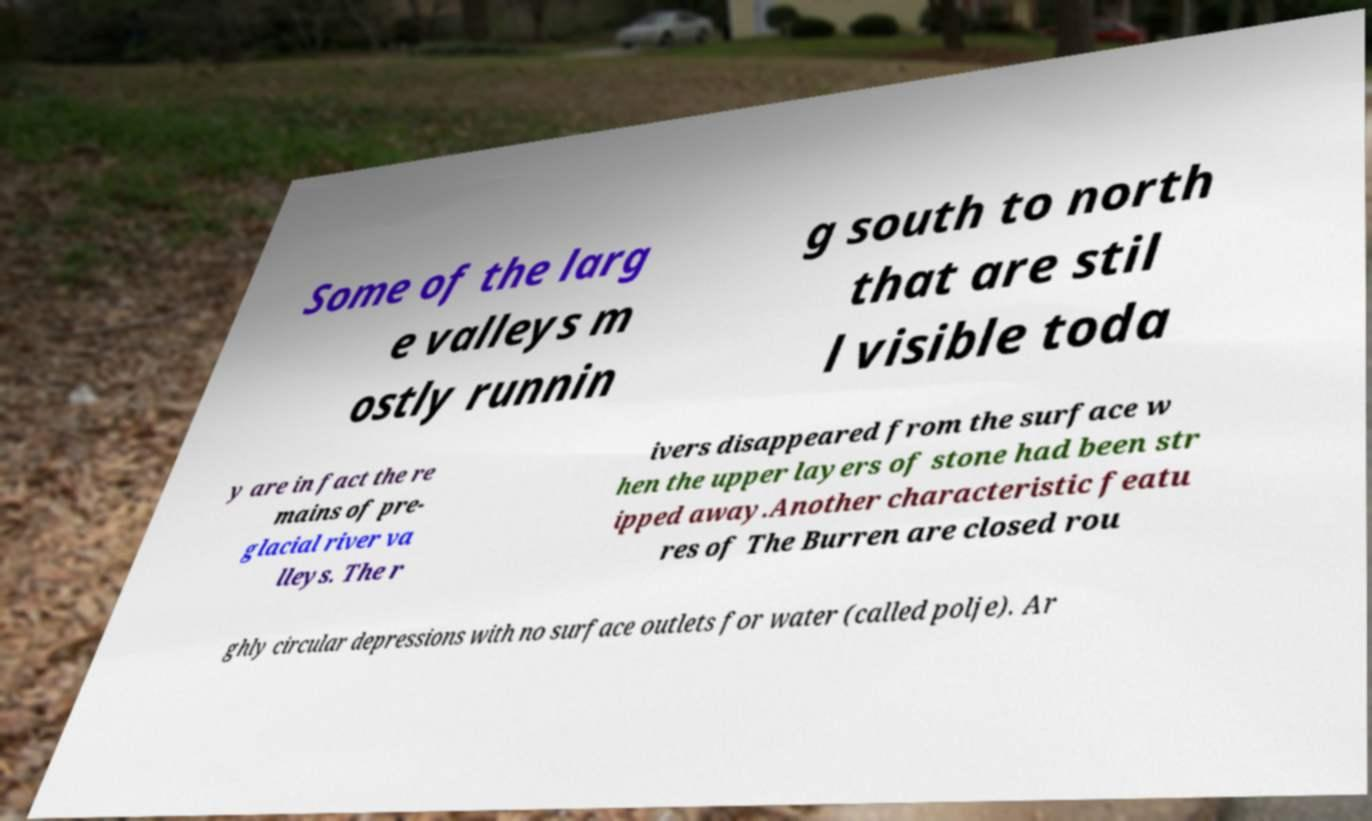For documentation purposes, I need the text within this image transcribed. Could you provide that? Some of the larg e valleys m ostly runnin g south to north that are stil l visible toda y are in fact the re mains of pre- glacial river va lleys. The r ivers disappeared from the surface w hen the upper layers of stone had been str ipped away.Another characteristic featu res of The Burren are closed rou ghly circular depressions with no surface outlets for water (called polje). Ar 